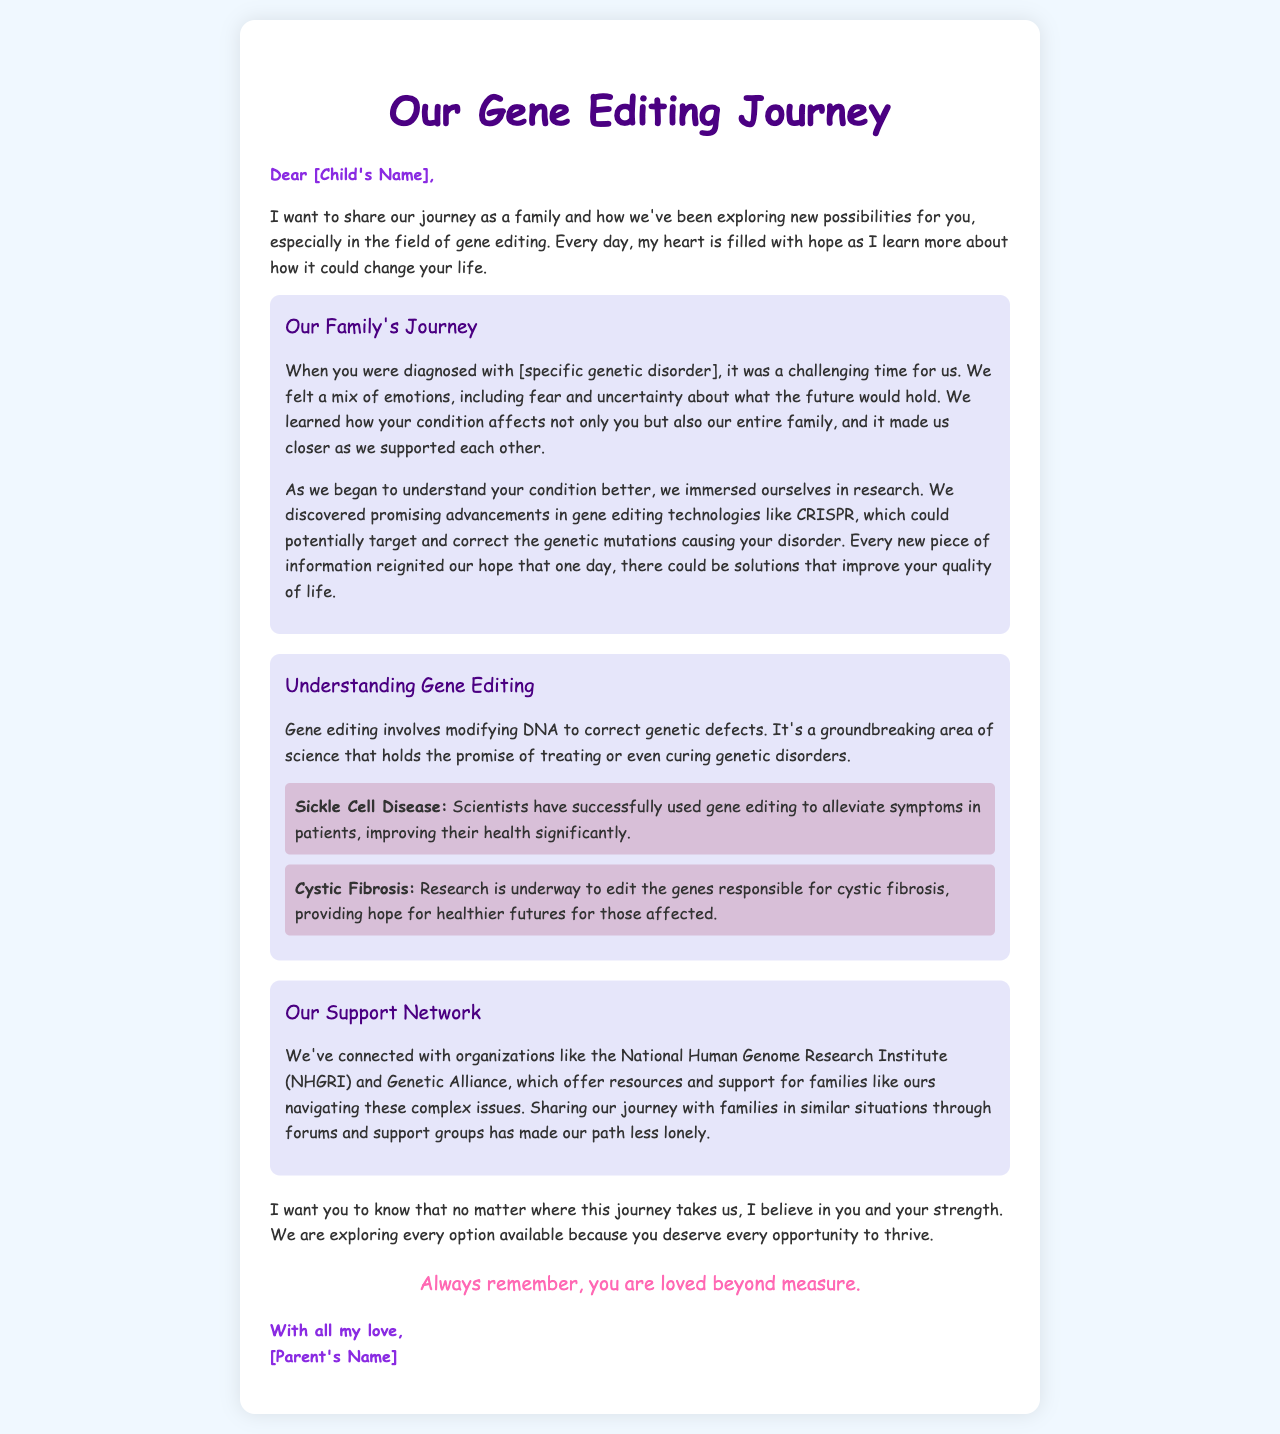what is the title of the letter? The title is displayed prominently at the top of the document.
Answer: Our Gene Editing Journey who is the letter addressed to? The greeting line specifies the recipient of the letter.
Answer: [Child's Name] what technology is mentioned as promising for gene editing? The document specifically names a technology relevant to gene editing advancements.
Answer: CRISPR which organizations are mentioned as part of the support network? The document lists organizations that provide resources for families.
Answer: National Human Genome Research Institute, Genetic Alliance what genetic disorder is mentioned in the document? The document refers to a specific genetic disorder affecting the child but does not name it.
Answer: [specific genetic disorder] what is one example of a genetic disorder that gene editing has helped? The letter provides specific examples of genetic disorders that have benefited from gene editing.
Answer: Sickle Cell Disease how does the parent feel about their child's journey? The document conveys the parent's emotional perspective regarding the journey and the child's strength.
Answer: Hopeful what is the closing line of the letter? The closing section includes a personal sentiment from the parent.
Answer: Always remember, you are loved beyond measure 